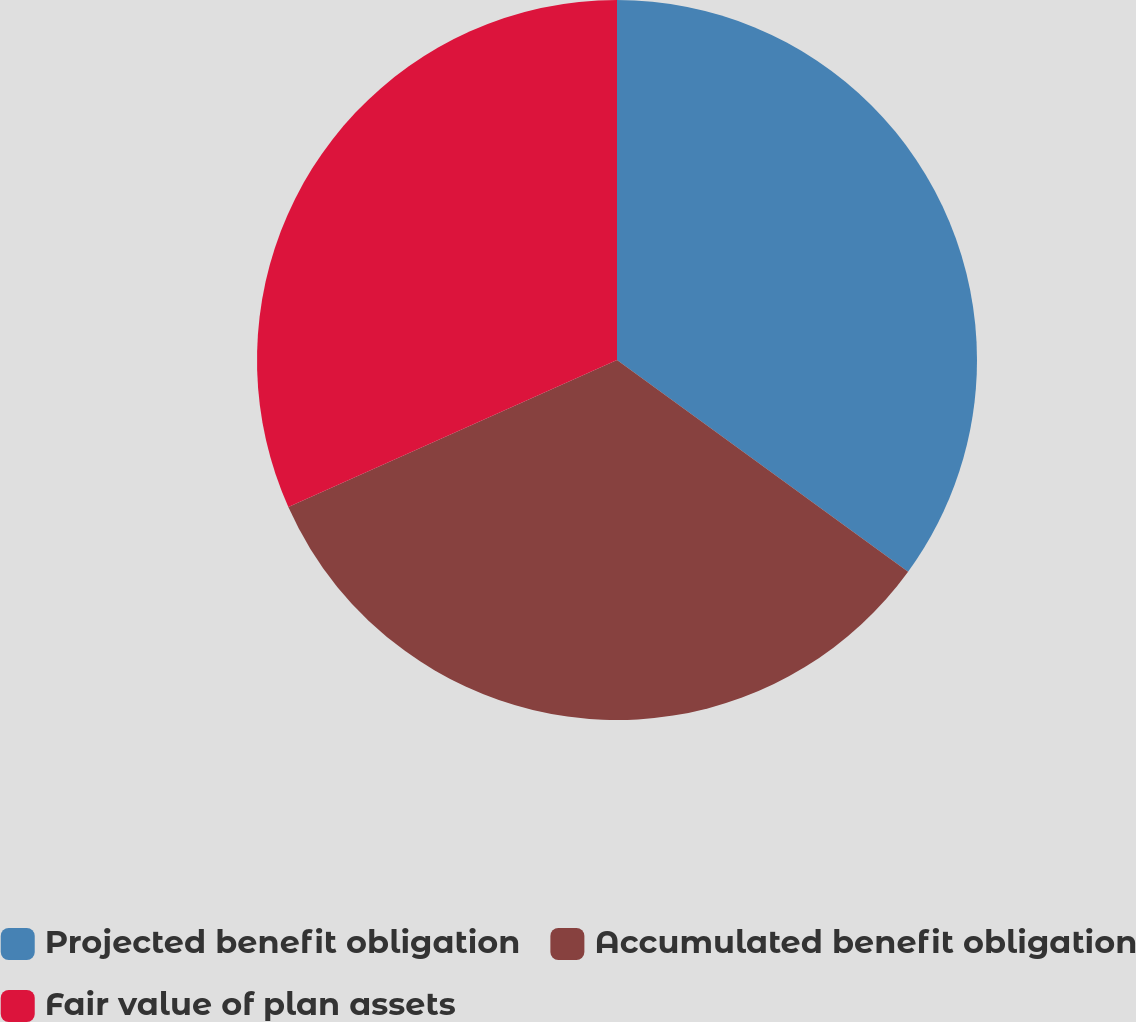Convert chart to OTSL. <chart><loc_0><loc_0><loc_500><loc_500><pie_chart><fcel>Projected benefit obligation<fcel>Accumulated benefit obligation<fcel>Fair value of plan assets<nl><fcel>35.01%<fcel>33.3%<fcel>31.69%<nl></chart> 